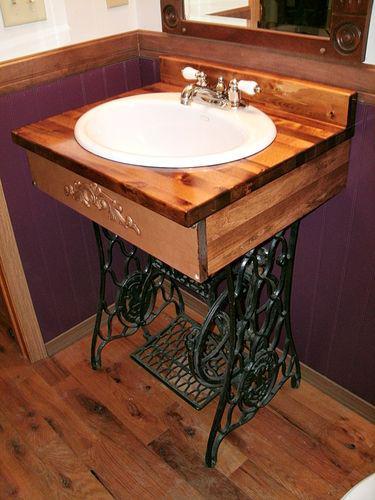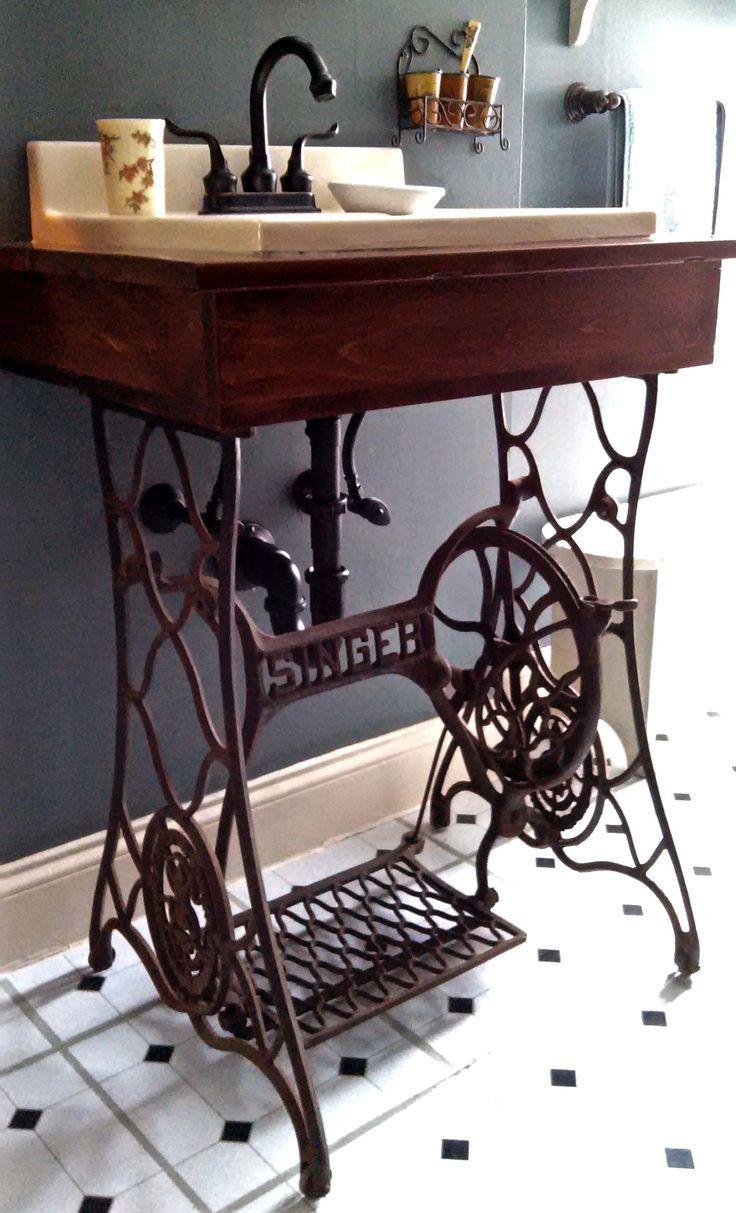The first image is the image on the left, the second image is the image on the right. Analyze the images presented: Is the assertion "Each image shows a dark metal sewing machine base used as part of a sink vanity, and at least one image features a wood grain counter that holds the sink." valid? Answer yes or no. Yes. The first image is the image on the left, the second image is the image on the right. Evaluate the accuracy of this statement regarding the images: "Both images show a sewing table with a black metal base converted into a bathroom sink.". Is it true? Answer yes or no. Yes. 